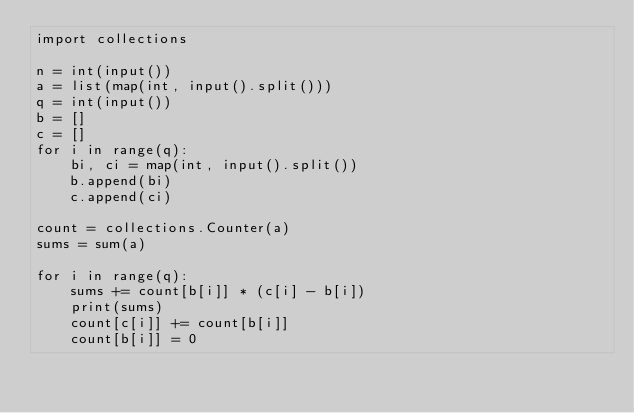<code> <loc_0><loc_0><loc_500><loc_500><_Python_>import collections

n = int(input())
a = list(map(int, input().split()))
q = int(input())
b = []
c = []
for i in range(q):
    bi, ci = map(int, input().split())
    b.append(bi)
    c.append(ci)

count = collections.Counter(a)
sums = sum(a)

for i in range(q):
    sums += count[b[i]] * (c[i] - b[i])
    print(sums)
    count[c[i]] += count[b[i]]
    count[b[i]] = 0
</code> 